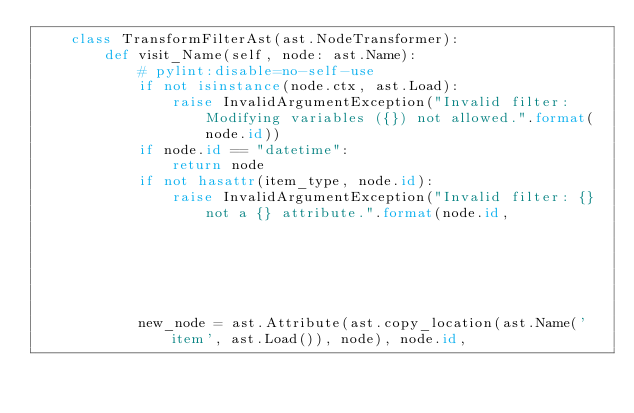<code> <loc_0><loc_0><loc_500><loc_500><_Python_>    class TransformFilterAst(ast.NodeTransformer):
        def visit_Name(self, node: ast.Name):
            # pylint:disable=no-self-use
            if not isinstance(node.ctx, ast.Load):
                raise InvalidArgumentException("Invalid filter: Modifying variables ({}) not allowed.".format(node.id))
            if node.id == "datetime":
                return node
            if not hasattr(item_type, node.id):
                raise InvalidArgumentException("Invalid filter: {} not a {} attribute.".format(node.id,
                                                                                               item_type.__name__))
            new_node = ast.Attribute(ast.copy_location(ast.Name('item', ast.Load()), node), node.id,</code> 